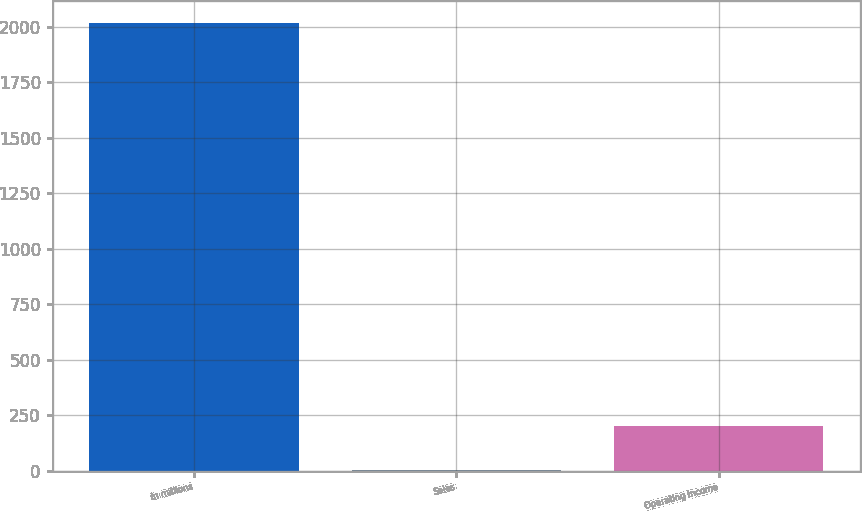Convert chart. <chart><loc_0><loc_0><loc_500><loc_500><bar_chart><fcel>in millions<fcel>Sales<fcel>Operating income<nl><fcel>2017<fcel>2<fcel>203.5<nl></chart> 